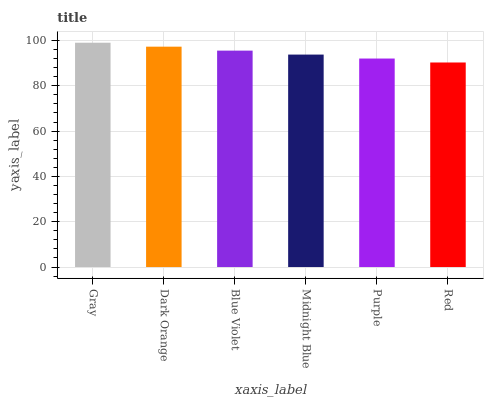Is Red the minimum?
Answer yes or no. Yes. Is Gray the maximum?
Answer yes or no. Yes. Is Dark Orange the minimum?
Answer yes or no. No. Is Dark Orange the maximum?
Answer yes or no. No. Is Gray greater than Dark Orange?
Answer yes or no. Yes. Is Dark Orange less than Gray?
Answer yes or no. Yes. Is Dark Orange greater than Gray?
Answer yes or no. No. Is Gray less than Dark Orange?
Answer yes or no. No. Is Blue Violet the high median?
Answer yes or no. Yes. Is Midnight Blue the low median?
Answer yes or no. Yes. Is Gray the high median?
Answer yes or no. No. Is Purple the low median?
Answer yes or no. No. 